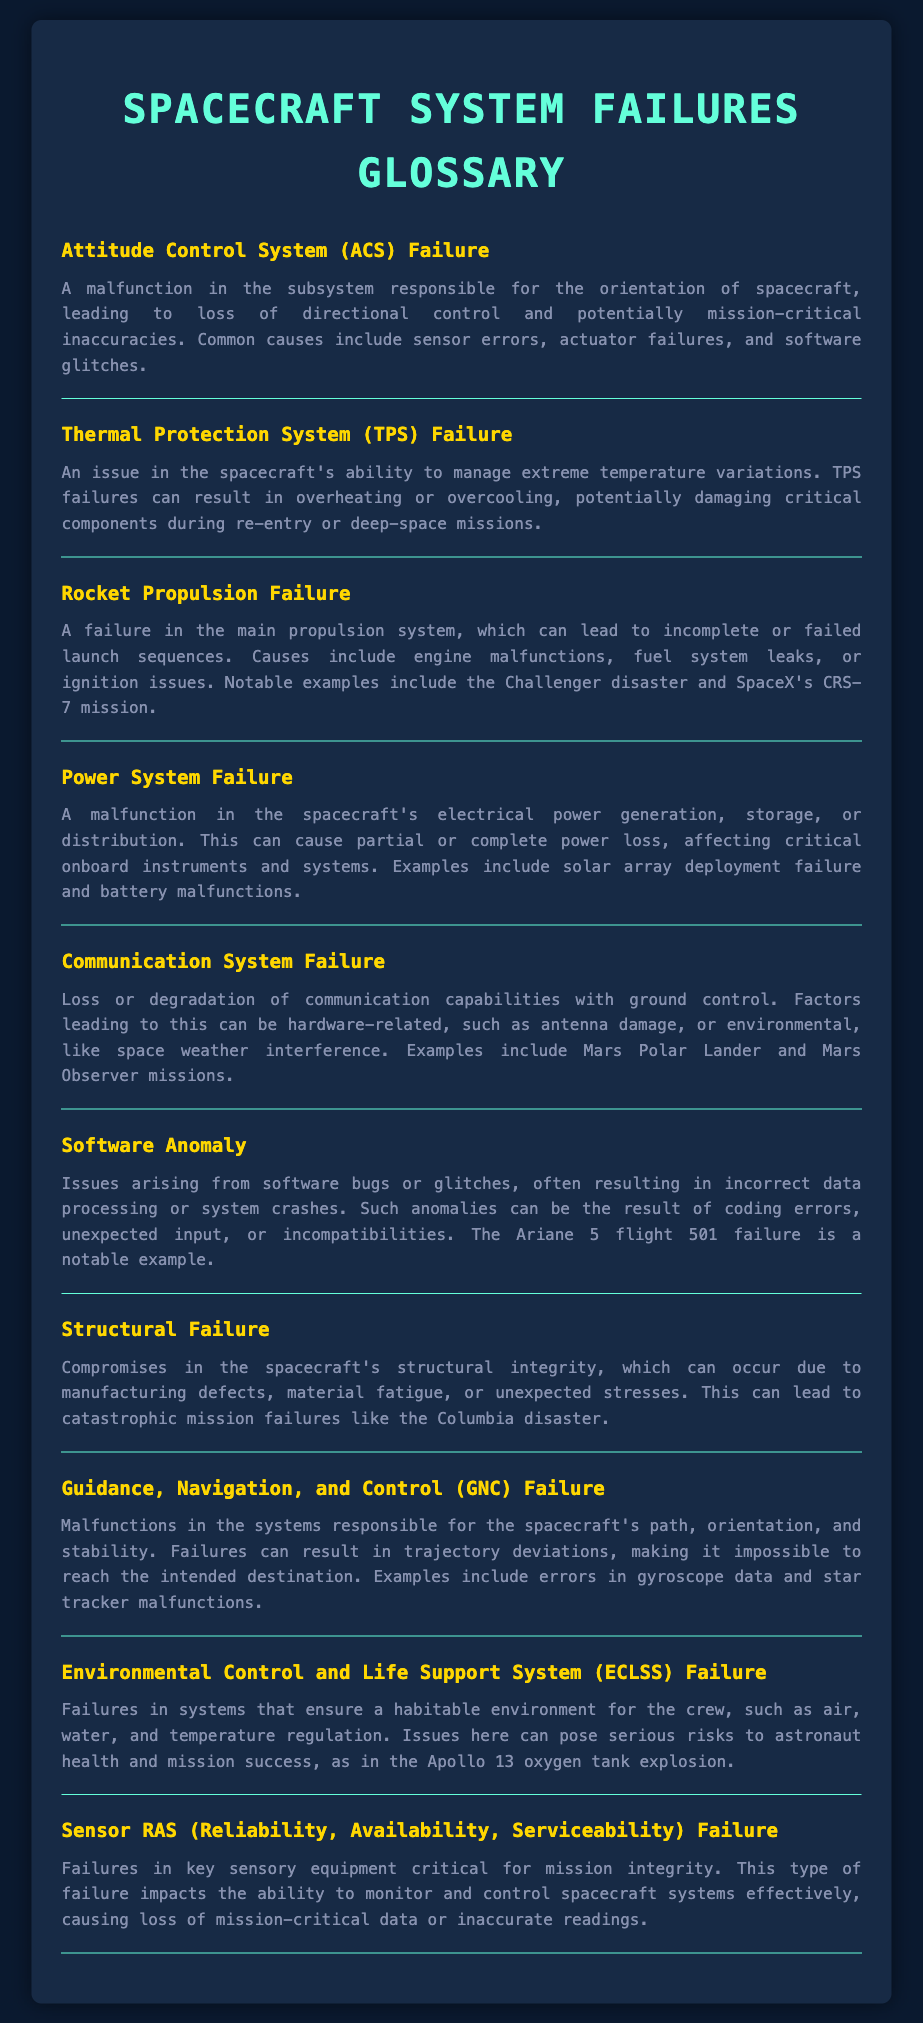What is ACS failure? ACS failure refers to a malfunction in the subsystem responsible for the orientation of spacecraft, leading to loss of directional control.
Answer: Attitude Control System (ACS) Failure What can TPS failures lead to? TPS failures can result in overheating or overcooling, potentially damaging critical components during re-entry or deep-space missions.
Answer: Overheating or overcooling Which notable incidents are associated with Rocket Propulsion failure? Notable examples include the Challenger disaster and SpaceX's CRS-7 mission.
Answer: Challenger disaster and SpaceX's CRS-7 mission What is a common cause of Power System failure? Common causes include solar array deployment failure and battery malfunctions.
Answer: Solar array deployment failure and battery malfunctions What impact does Software Anomaly have on missions? Software Anomalies often result in incorrect data processing or system crashes.
Answer: Incorrect data processing or system crashes Which failure can result from material fatigue? Compromises in structural integrity can occur due to manufacturing defects, material fatigue, or unexpected stresses.
Answer: Structural Failure What role does environmental control play in ECLSS failure? ECLSS failures can pose serious risks to astronaut health and mission success.
Answer: Astronaut health and mission success What does GNC stand for? GNC stands for Guidance, Navigation, and Control.
Answer: Guidance, Navigation, and Control What is the result of Sensor RAS failure? Sensor RAS failure causes loss of mission-critical data or inaccurate readings.
Answer: Loss of mission-critical data or inaccurate readings What can affect communication in space missions? Communication System Failure can be affected by hardware-related issues or environmental factors.
Answer: Hardware-related issues or environmental factors 